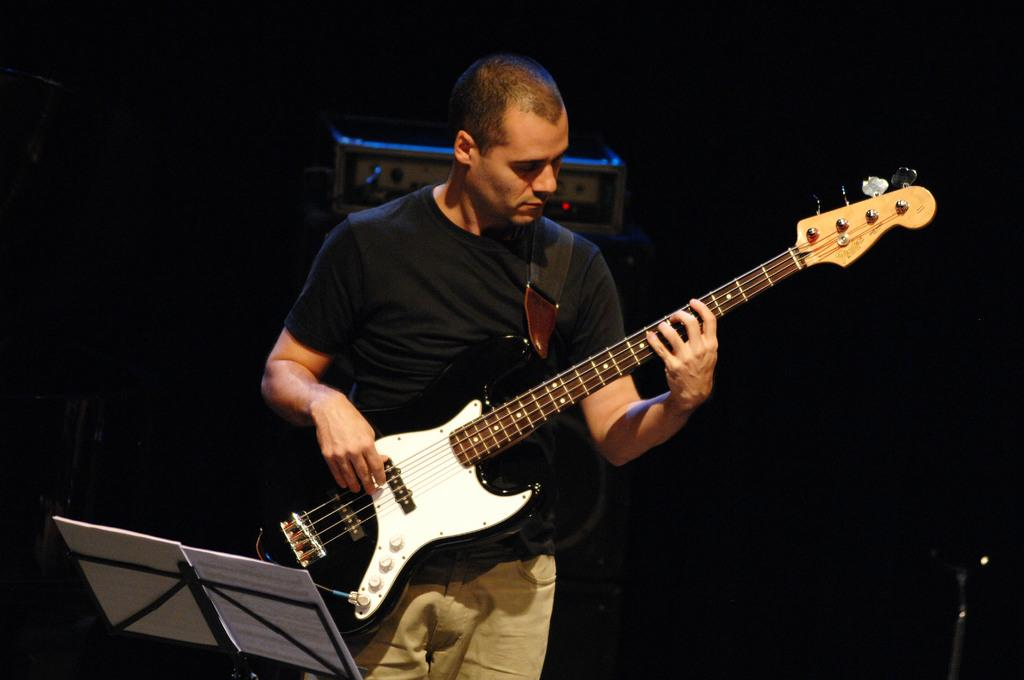What is the man in the image doing? The man is playing a guitar in the image. What might the paper in front of the man be related to? The paper in front of the man could be related to sheet music or lyrics for the song he is playing. What is the purpose of the amplifier visible behind the man? The amplifier is likely used to increase the volume of the guitar's sound. What type of work error can be seen on the paper in front of the man? There is no work error visible on the paper in front of the man; it is not mentioned in the provided facts. 